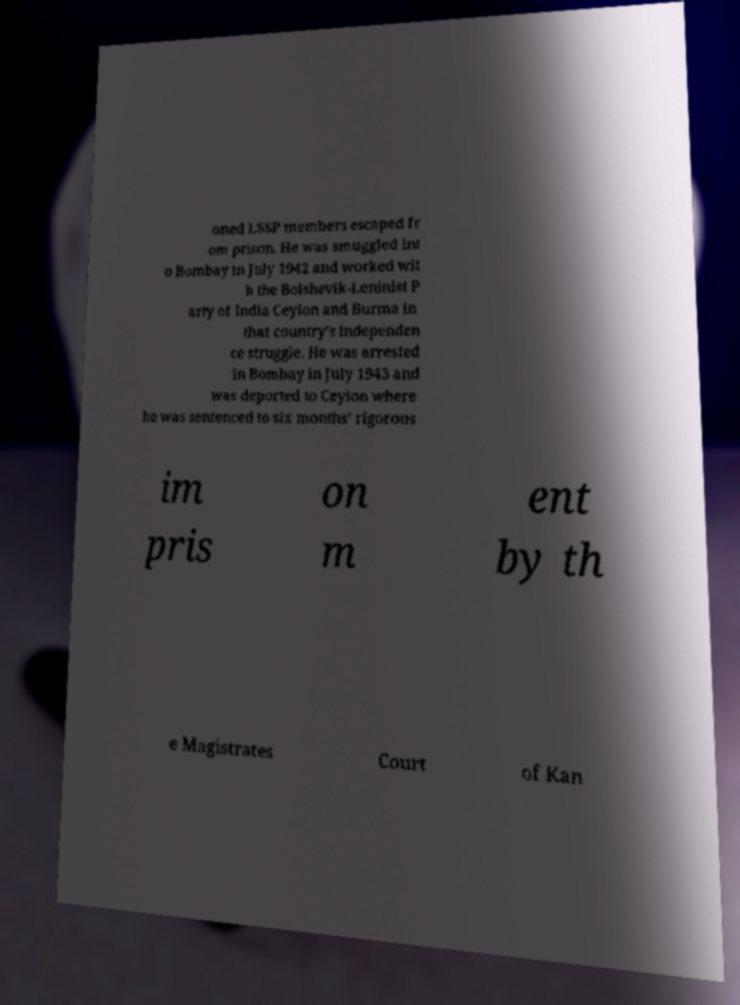There's text embedded in this image that I need extracted. Can you transcribe it verbatim? oned LSSP members escaped fr om prison. He was smuggled int o Bombay in July 1942 and worked wit h the Bolshevik-Leninist P arty of India Ceylon and Burma in that country's independen ce struggle. He was arrested in Bombay in July 1943 and was deported to Ceylon where he was sentenced to six months’ rigorous im pris on m ent by th e Magistrates Court of Kan 